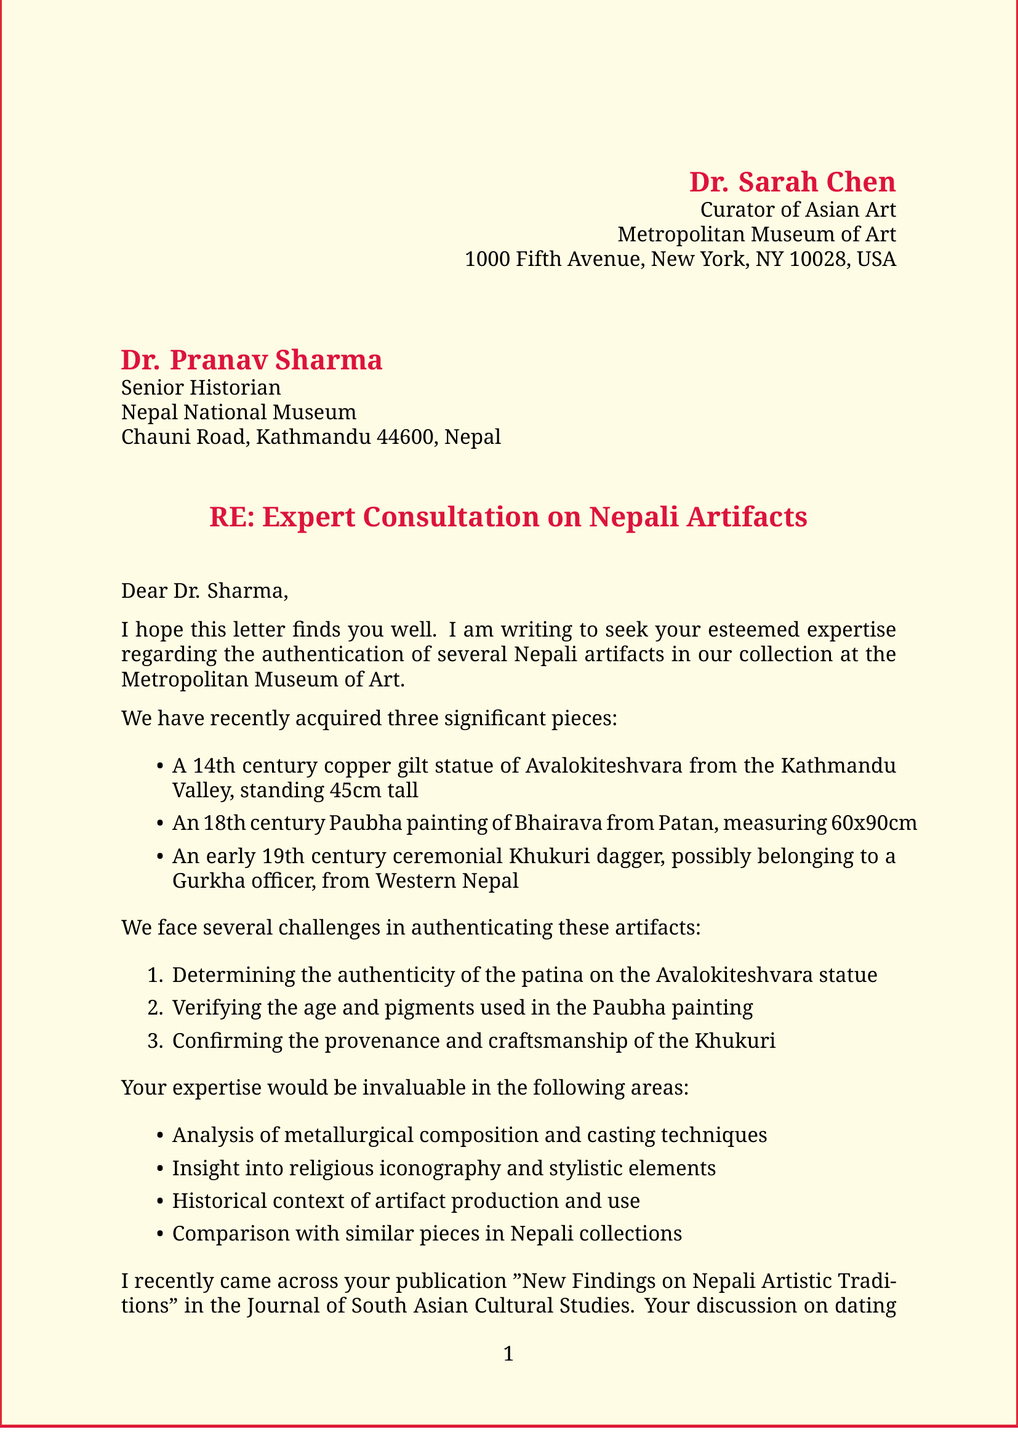What is the name of the sender? The sender of the letter is identified at the top of the document, stating "Dr. Sarah Chen."
Answer: Dr. Sarah Chen What is the title of the recipient? The title of the recipient is found in the greeting section, which specifies "Senior Historian."
Answer: Senior Historian What is the period of the Avalokiteshvara statue? The period of the statue is mentioned in the list of artifacts, stating "14th century."
Answer: 14th century What is the size of the Paubha painting? The dimensions of the Paubha painting are listed in the artifact description, stating "60x90cm."
Answer: 60x90cm What is one challenge mentioned in authenticating the Khukuri? One of the challenges listed for the Khukuri is "Confirming the provenance and craftsmanship."
Answer: Confirming the provenance and craftsmanship What collaboration is proposed in the letter? The letter proposes "a joint research project on Nepali artifacts in Western museums."
Answer: joint research project on Nepali artifacts in Western museums What is the publication title mentioned in the recent research? The title of the publication referenced is "New Findings on Nepali Artistic Traditions."
Answer: New Findings on Nepali Artistic Traditions How many artifacts are discussed in the letter? The document lists three significant pieces that are discussed regarding authentication.
Answer: three What is the purpose of the proposed collaboration? The proposal's purpose is mentioned as promoting "Nepali cultural heritage internationally."
Answer: promoting Nepali cultural heritage internationally What is the closing sentiment expressed by the sender? The closing remarks express an appreciation for Dr. Sharma's expertise and time in the letter.
Answer: appreciation for Dr. Sharma's expertise and time 